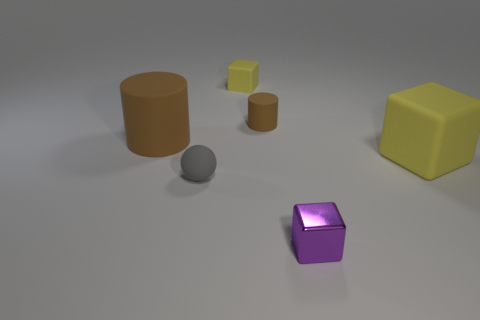The other matte cylinder that is the same color as the big cylinder is what size?
Provide a short and direct response. Small. What number of objects are the same color as the small matte block?
Your answer should be very brief. 1. There is a purple thing that is the same shape as the tiny yellow object; what is it made of?
Your answer should be compact. Metal. What shape is the tiny yellow thing that is made of the same material as the gray thing?
Give a very brief answer. Cube. Is the shape of the yellow matte thing that is to the left of the purple cube the same as  the large brown object?
Provide a short and direct response. No. How many brown objects are either large cylinders or tiny rubber cylinders?
Your answer should be compact. 2. Are there an equal number of big yellow rubber blocks that are in front of the matte sphere and yellow rubber things that are left of the small yellow matte cube?
Your answer should be compact. Yes. There is a matte cylinder that is right of the matte block on the left side of the big rubber thing that is in front of the big brown cylinder; what is its color?
Offer a very short reply. Brown. Is there anything else that has the same color as the big cylinder?
Keep it short and to the point. Yes. There is a object that is the same color as the big matte cylinder; what is its shape?
Your answer should be very brief. Cylinder. 